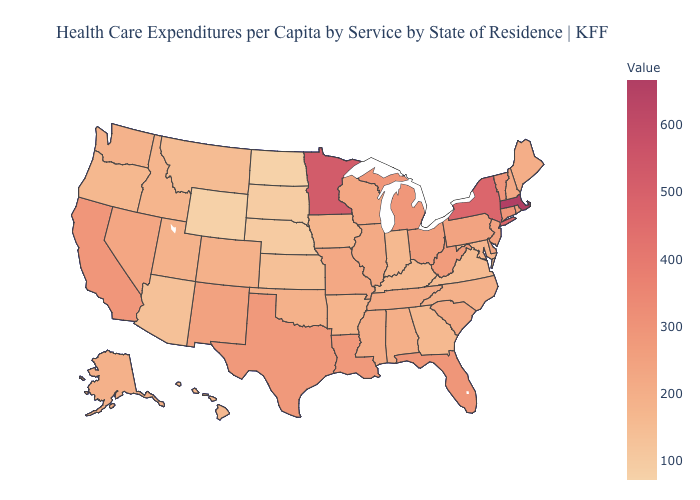Is the legend a continuous bar?
Keep it brief. Yes. Does Massachusetts have the highest value in the Northeast?
Keep it brief. Yes. Does Virginia have the lowest value in the South?
Short answer required. Yes. Which states hav the highest value in the West?
Concise answer only. California. 